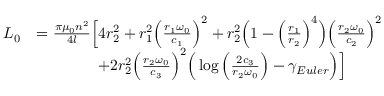Convert formula to latex. <formula><loc_0><loc_0><loc_500><loc_500>\begin{array} { r l } { L _ { 0 } } & { = \frac { \pi \mu _ { 0 } n ^ { 2 } } { 4 l } \left [ 4 r _ { 2 } ^ { 2 } + r _ { 1 } ^ { 2 } \left ( \frac { r _ { 1 } \omega _ { 0 } } { c _ { 1 } } \right ) ^ { 2 } + r _ { 2 } ^ { 2 } \left ( 1 - \left ( \frac { r _ { 1 } } { r _ { 2 } } \right ) ^ { 4 } \right ) \left ( \frac { r _ { 2 } \omega _ { 0 } } { c _ { 2 } } \right ) ^ { 2 } } \\ & { \quad + 2 r _ { 2 } ^ { 2 } \left ( \frac { r _ { 2 } \omega _ { 0 } } { c _ { 3 } } \right ) ^ { 2 } \left ( \log \left ( \frac { 2 c _ { 3 } } { r _ { 2 } \omega _ { 0 } } \right ) - \gamma _ { E u l e r } \right ) \right ] } \end{array}</formula> 